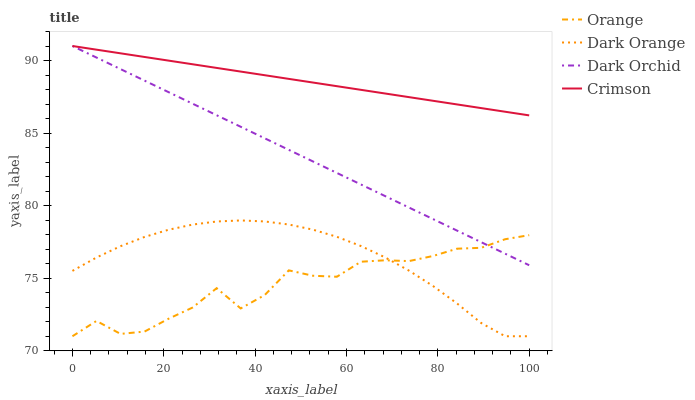Does Orange have the minimum area under the curve?
Answer yes or no. Yes. Does Crimson have the maximum area under the curve?
Answer yes or no. Yes. Does Dark Orange have the minimum area under the curve?
Answer yes or no. No. Does Dark Orange have the maximum area under the curve?
Answer yes or no. No. Is Crimson the smoothest?
Answer yes or no. Yes. Is Orange the roughest?
Answer yes or no. Yes. Is Dark Orange the smoothest?
Answer yes or no. No. Is Dark Orange the roughest?
Answer yes or no. No. Does Crimson have the lowest value?
Answer yes or no. No. Does Dark Orchid have the highest value?
Answer yes or no. Yes. Does Dark Orange have the highest value?
Answer yes or no. No. Is Dark Orange less than Crimson?
Answer yes or no. Yes. Is Dark Orchid greater than Dark Orange?
Answer yes or no. Yes. Does Orange intersect Dark Orange?
Answer yes or no. Yes. Is Orange less than Dark Orange?
Answer yes or no. No. Is Orange greater than Dark Orange?
Answer yes or no. No. Does Dark Orange intersect Crimson?
Answer yes or no. No. 